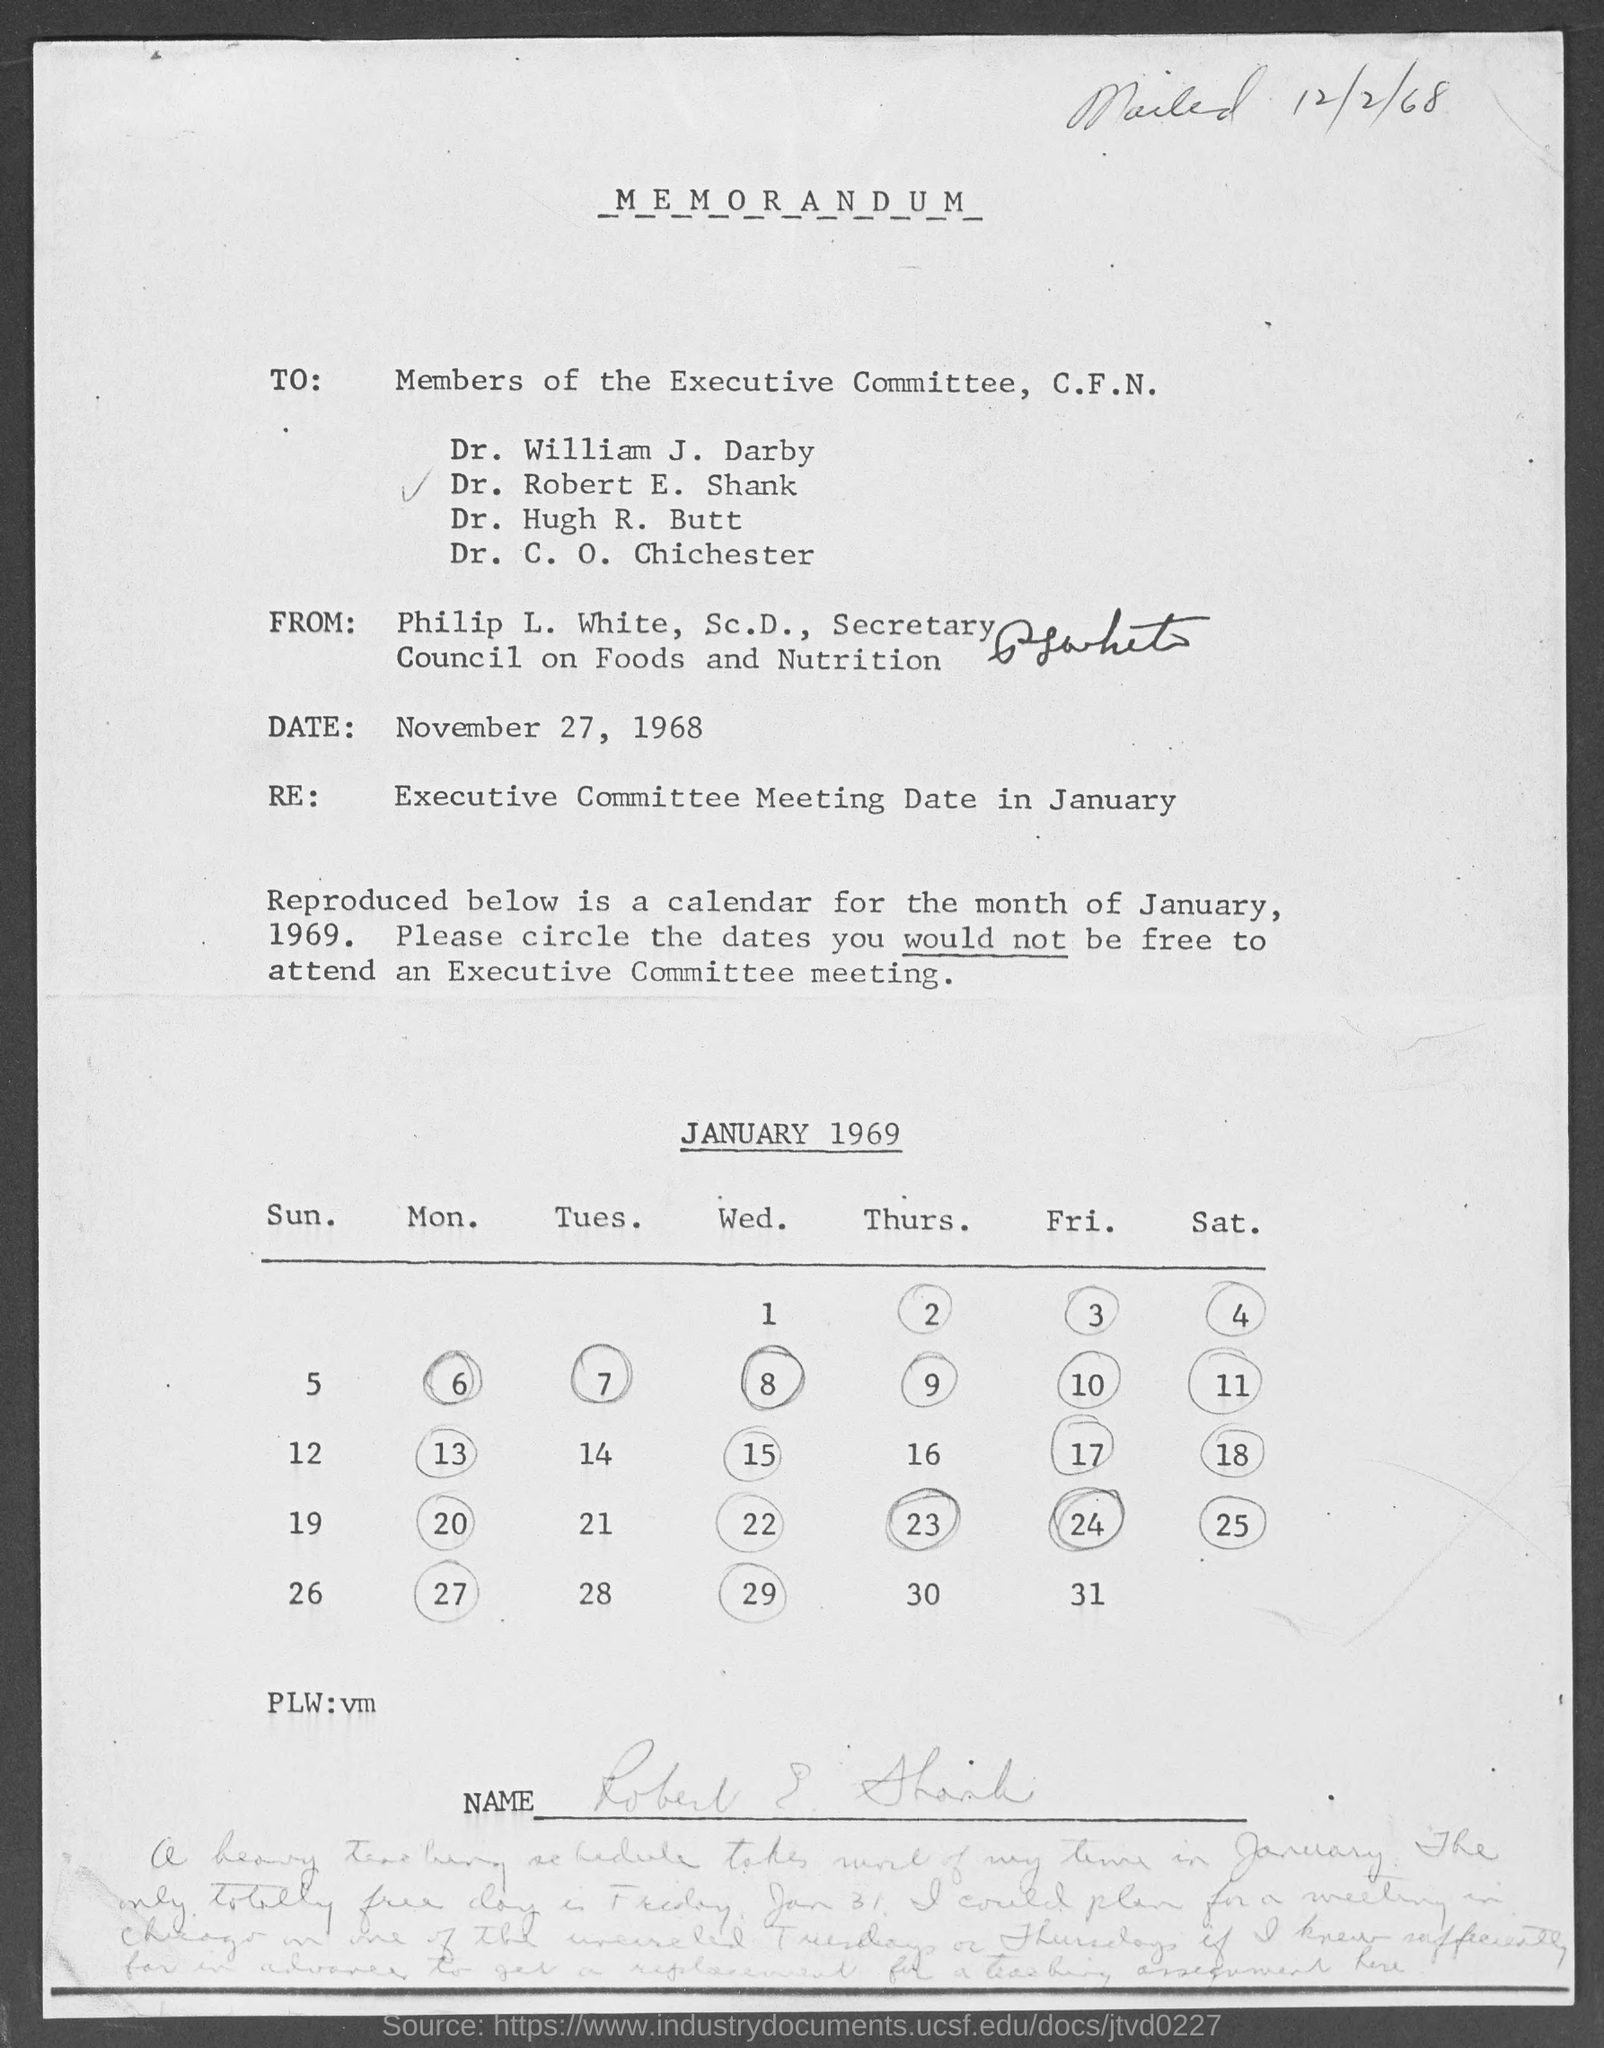What is the position of philip l. white, sc.d.,?
Give a very brief answer. Secretary. When is the memorandum dated?
Your response must be concise. November  27, 1968. What is the subject of the memorandum?
Keep it short and to the point. Executive committee meeting date in january. 